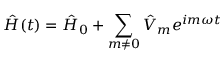Convert formula to latex. <formula><loc_0><loc_0><loc_500><loc_500>\hat { H } ( t ) = \hat { H } _ { 0 } + \sum _ { m \neq 0 } \hat { V } _ { m } e ^ { i m \omega t }</formula> 